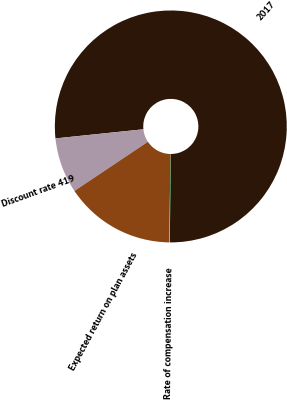<chart> <loc_0><loc_0><loc_500><loc_500><pie_chart><fcel>2017<fcel>Discount rate 419<fcel>Expected return on plan assets<fcel>Rate of compensation increase<nl><fcel>76.77%<fcel>7.74%<fcel>15.41%<fcel>0.07%<nl></chart> 